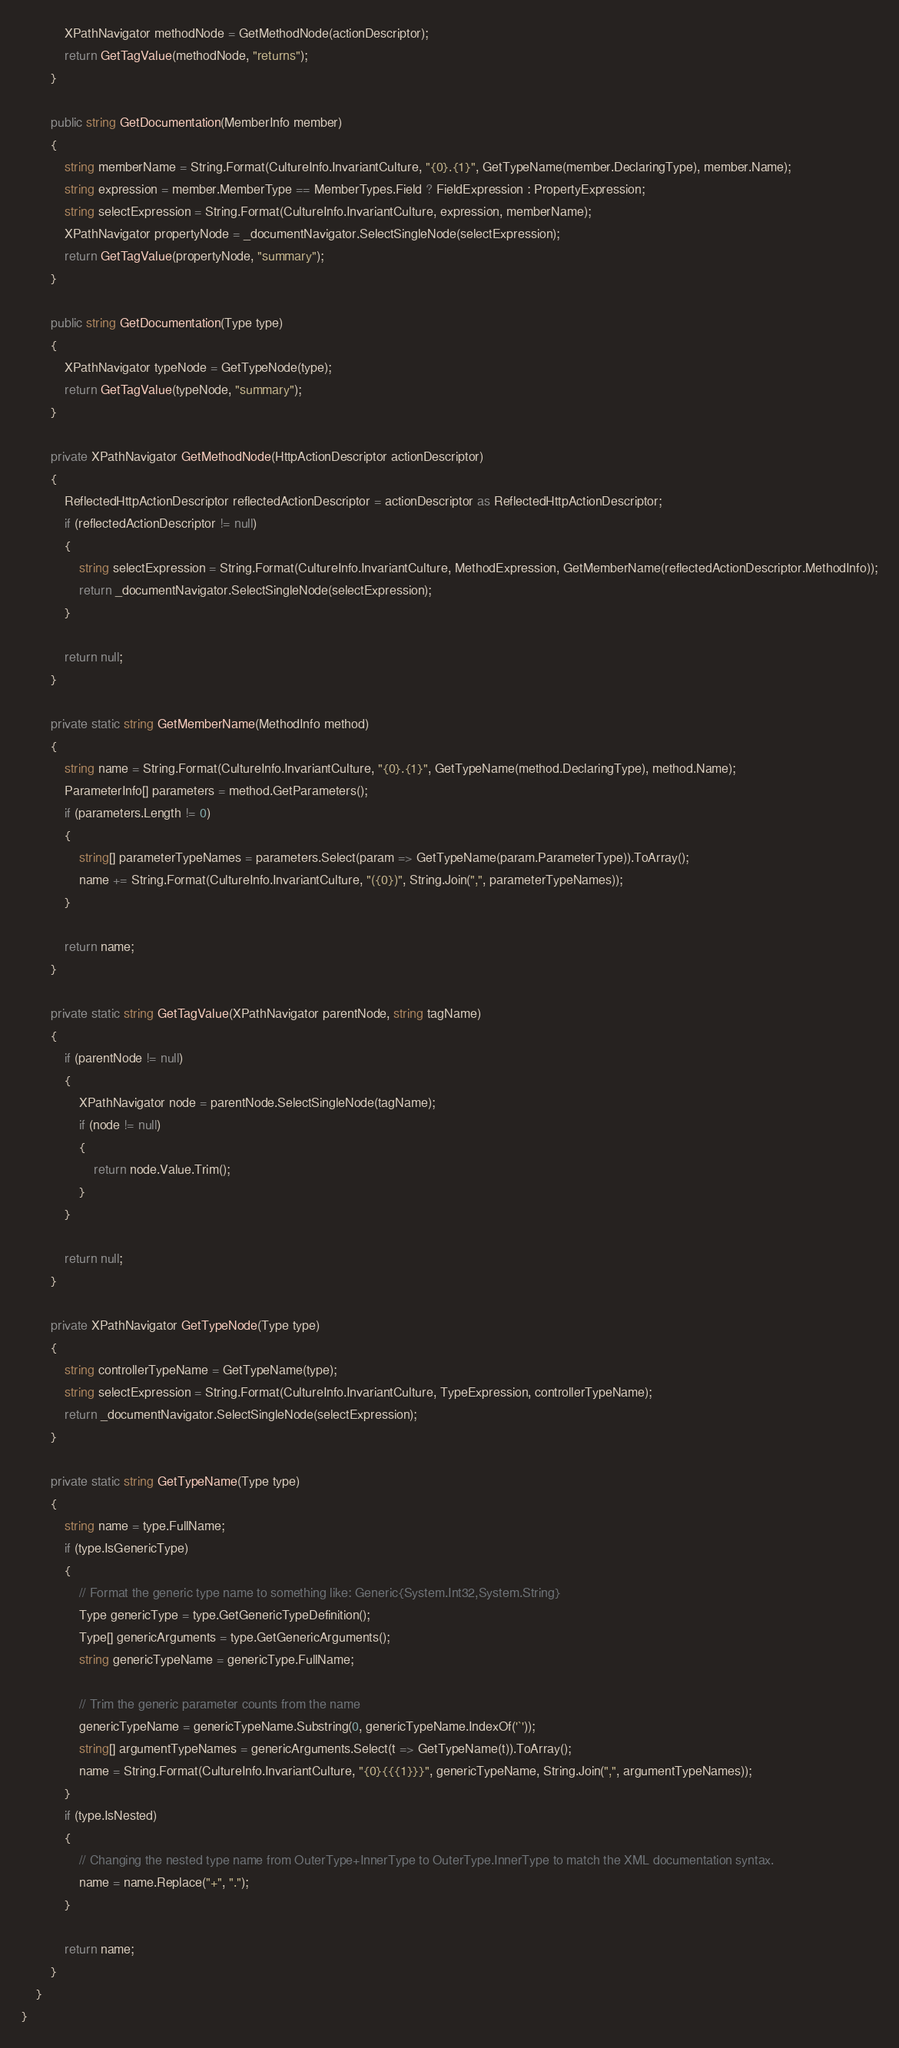Convert code to text. <code><loc_0><loc_0><loc_500><loc_500><_C#_>            XPathNavigator methodNode = GetMethodNode(actionDescriptor);
            return GetTagValue(methodNode, "returns");
        }

        public string GetDocumentation(MemberInfo member)
        {
            string memberName = String.Format(CultureInfo.InvariantCulture, "{0}.{1}", GetTypeName(member.DeclaringType), member.Name);
            string expression = member.MemberType == MemberTypes.Field ? FieldExpression : PropertyExpression;
            string selectExpression = String.Format(CultureInfo.InvariantCulture, expression, memberName);
            XPathNavigator propertyNode = _documentNavigator.SelectSingleNode(selectExpression);
            return GetTagValue(propertyNode, "summary");
        }

        public string GetDocumentation(Type type)
        {
            XPathNavigator typeNode = GetTypeNode(type);
            return GetTagValue(typeNode, "summary");
        }

        private XPathNavigator GetMethodNode(HttpActionDescriptor actionDescriptor)
        {
            ReflectedHttpActionDescriptor reflectedActionDescriptor = actionDescriptor as ReflectedHttpActionDescriptor;
            if (reflectedActionDescriptor != null)
            {
                string selectExpression = String.Format(CultureInfo.InvariantCulture, MethodExpression, GetMemberName(reflectedActionDescriptor.MethodInfo));
                return _documentNavigator.SelectSingleNode(selectExpression);
            }

            return null;
        }

        private static string GetMemberName(MethodInfo method)
        {
            string name = String.Format(CultureInfo.InvariantCulture, "{0}.{1}", GetTypeName(method.DeclaringType), method.Name);
            ParameterInfo[] parameters = method.GetParameters();
            if (parameters.Length != 0)
            {
                string[] parameterTypeNames = parameters.Select(param => GetTypeName(param.ParameterType)).ToArray();
                name += String.Format(CultureInfo.InvariantCulture, "({0})", String.Join(",", parameterTypeNames));
            }

            return name;
        }

        private static string GetTagValue(XPathNavigator parentNode, string tagName)
        {
            if (parentNode != null)
            {
                XPathNavigator node = parentNode.SelectSingleNode(tagName);
                if (node != null)
                {
                    return node.Value.Trim();
                }
            }

            return null;
        }

        private XPathNavigator GetTypeNode(Type type)
        {
            string controllerTypeName = GetTypeName(type);
            string selectExpression = String.Format(CultureInfo.InvariantCulture, TypeExpression, controllerTypeName);
            return _documentNavigator.SelectSingleNode(selectExpression);
        }

        private static string GetTypeName(Type type)
        {
            string name = type.FullName;
            if (type.IsGenericType)
            {
                // Format the generic type name to something like: Generic{System.Int32,System.String}
                Type genericType = type.GetGenericTypeDefinition();
                Type[] genericArguments = type.GetGenericArguments();
                string genericTypeName = genericType.FullName;

                // Trim the generic parameter counts from the name
                genericTypeName = genericTypeName.Substring(0, genericTypeName.IndexOf('`'));
                string[] argumentTypeNames = genericArguments.Select(t => GetTypeName(t)).ToArray();
                name = String.Format(CultureInfo.InvariantCulture, "{0}{{{1}}}", genericTypeName, String.Join(",", argumentTypeNames));
            }
            if (type.IsNested)
            {
                // Changing the nested type name from OuterType+InnerType to OuterType.InnerType to match the XML documentation syntax.
                name = name.Replace("+", ".");
            }

            return name;
        }
    }
}
</code> 